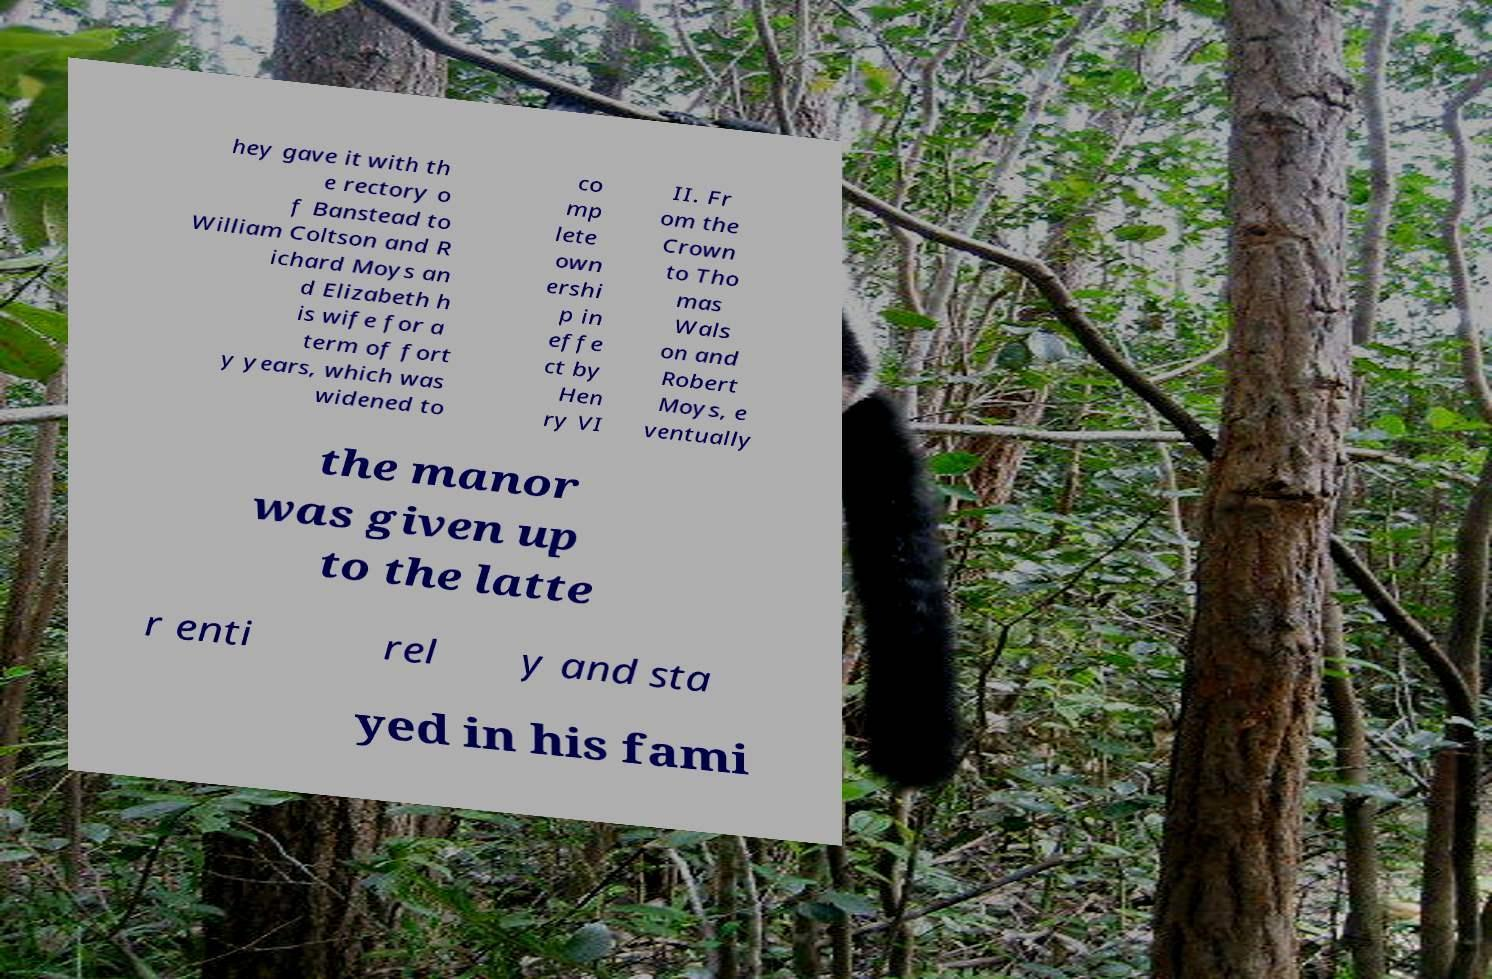Please read and relay the text visible in this image. What does it say? hey gave it with th e rectory o f Banstead to William Coltson and R ichard Moys an d Elizabeth h is wife for a term of fort y years, which was widened to co mp lete own ershi p in effe ct by Hen ry VI II. Fr om the Crown to Tho mas Wals on and Robert Moys, e ventually the manor was given up to the latte r enti rel y and sta yed in his fami 